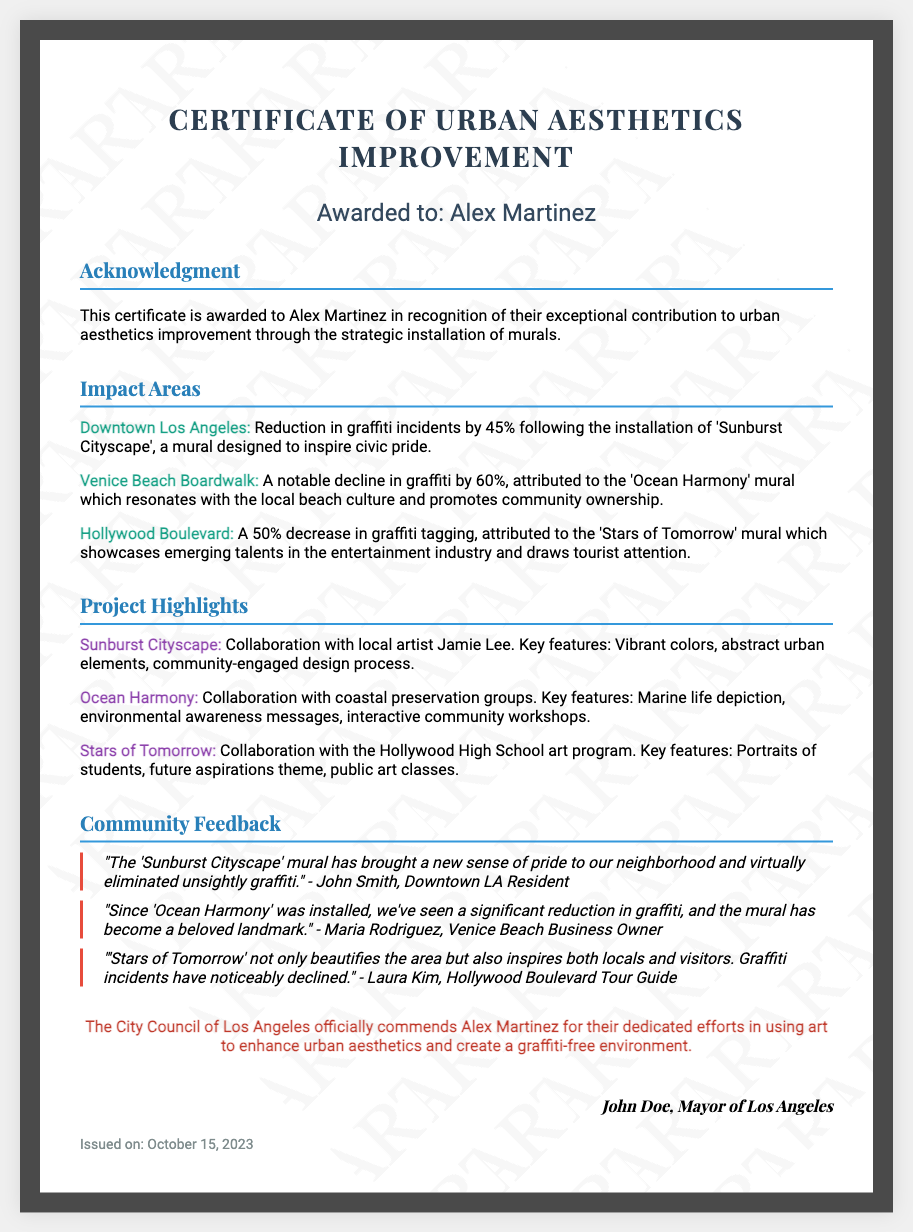What is the name of the mural in Downtown Los Angeles? The document specifies that the mural in Downtown Los Angeles is 'Sunburst Cityscape'.
Answer: Sunburst Cityscape What percentage reduction in graffiti incidents was noted at Venice Beach Boardwalk? The document states that graffiti incidents declined by 60% at Venice Beach Boardwalk.
Answer: 60% Who collaborated on the 'Stars of Tomorrow' mural? The document mentions that the 'Stars of Tomorrow' mural was a collaboration with the Hollywood High School art program.
Answer: Hollywood High School art program What is the date of issue for this certificate? The certificate states it was issued on October 15, 2023.
Answer: October 15, 2023 What feedback was given about the 'Ocean Harmony' mural? According to the document, Maria Rodriguez, a Venice Beach Business Owner, stated that the mural has become a beloved landmark following its installation.
Answer: A beloved landmark How many impact areas are listed in the document? There are three impact areas mentioned for graffiti reduction in the document.
Answer: Three What is the official title of the document? The official title as stated in the document is 'Certificate of Urban Aesthetics Improvement'.
Answer: Certificate of Urban Aesthetics Improvement What is the name of the recipient of this certificate? The document indicates that the certificate is awarded to Alex Martinez.
Answer: Alex Martinez 